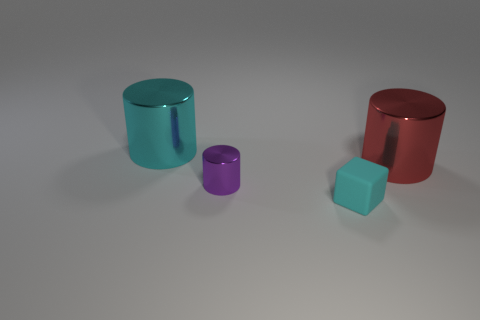Subtract all purple cylinders. How many cylinders are left? 2 Add 2 red cylinders. How many objects exist? 6 Subtract all cylinders. Subtract all yellow matte cylinders. How many objects are left? 1 Add 1 big cyan things. How many big cyan things are left? 2 Add 2 big brown things. How many big brown things exist? 2 Subtract 0 red blocks. How many objects are left? 4 Subtract all cylinders. How many objects are left? 1 